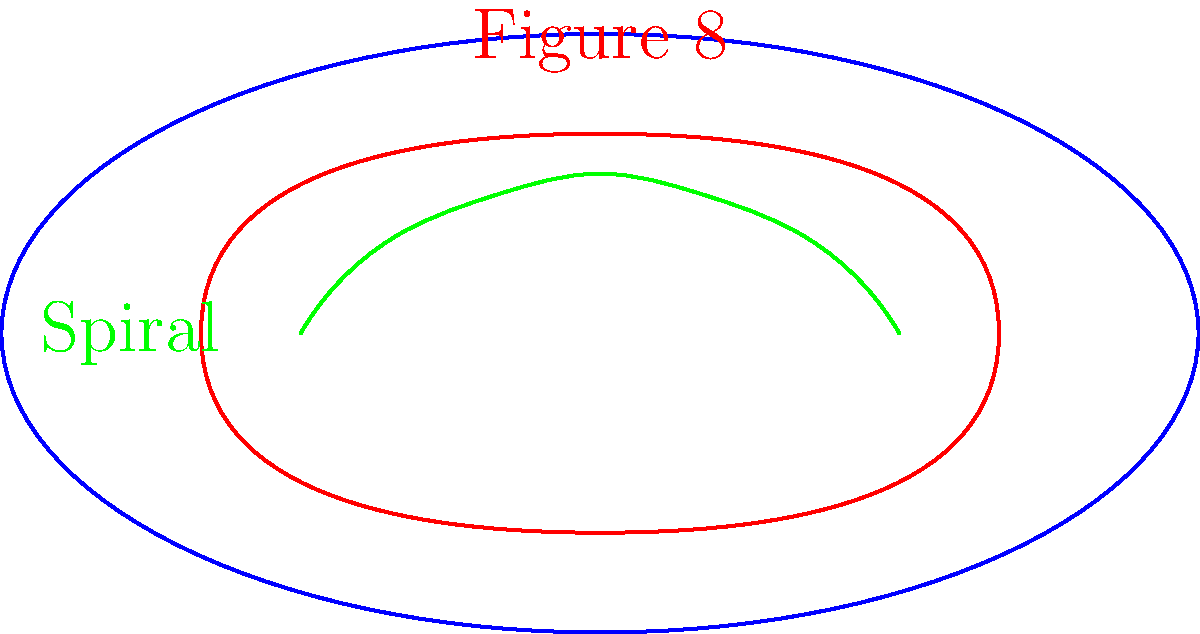In the context of figure skating paths on an ice rink, consider the topological properties of the figure-8 and spiral patterns shown in the diagram. Which of these paths is homeomorphic to a circle, and why? To determine which path is homeomorphic to a circle, we need to analyze the topological properties of both the figure-8 and spiral patterns:

1. Figure-8 path:
   - It's a closed loop that intersects itself at the center point.
   - It has a self-intersection, creating two distinct loops.
   - Topologically, it's equivalent to two circles touching at a single point.

2. Spiral path:
   - It's an open curve that doesn't form a closed loop.
   - It has distinct start and end points.
   - It doesn't intersect itself at any point.

3. Properties of a circle:
   - It's a simple closed curve without self-intersections.
   - It has no distinct start or end points.

4. Homeomorphism:
   - A homeomorphism is a continuous function between topological spaces that has a continuous inverse function.
   - For a curve to be homeomorphic to a circle, it must be possible to continuously deform it into a circle without breaking or creating new intersections.

5. Analysis:
   - The figure-8 path cannot be continuously deformed into a circle without breaking the self-intersection, so it's not homeomorphic to a circle.
   - The spiral path, while not closed, can be continuously deformed into a circle by connecting its endpoints. This transformation preserves its topological properties.

Therefore, the spiral path is homeomorphic to a circle, as it can be continuously deformed into a circle without changing its fundamental topological structure.
Answer: The spiral path 